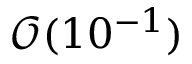Convert formula to latex. <formula><loc_0><loc_0><loc_500><loc_500>\mathcal { O } ( 1 0 ^ { - 1 } )</formula> 